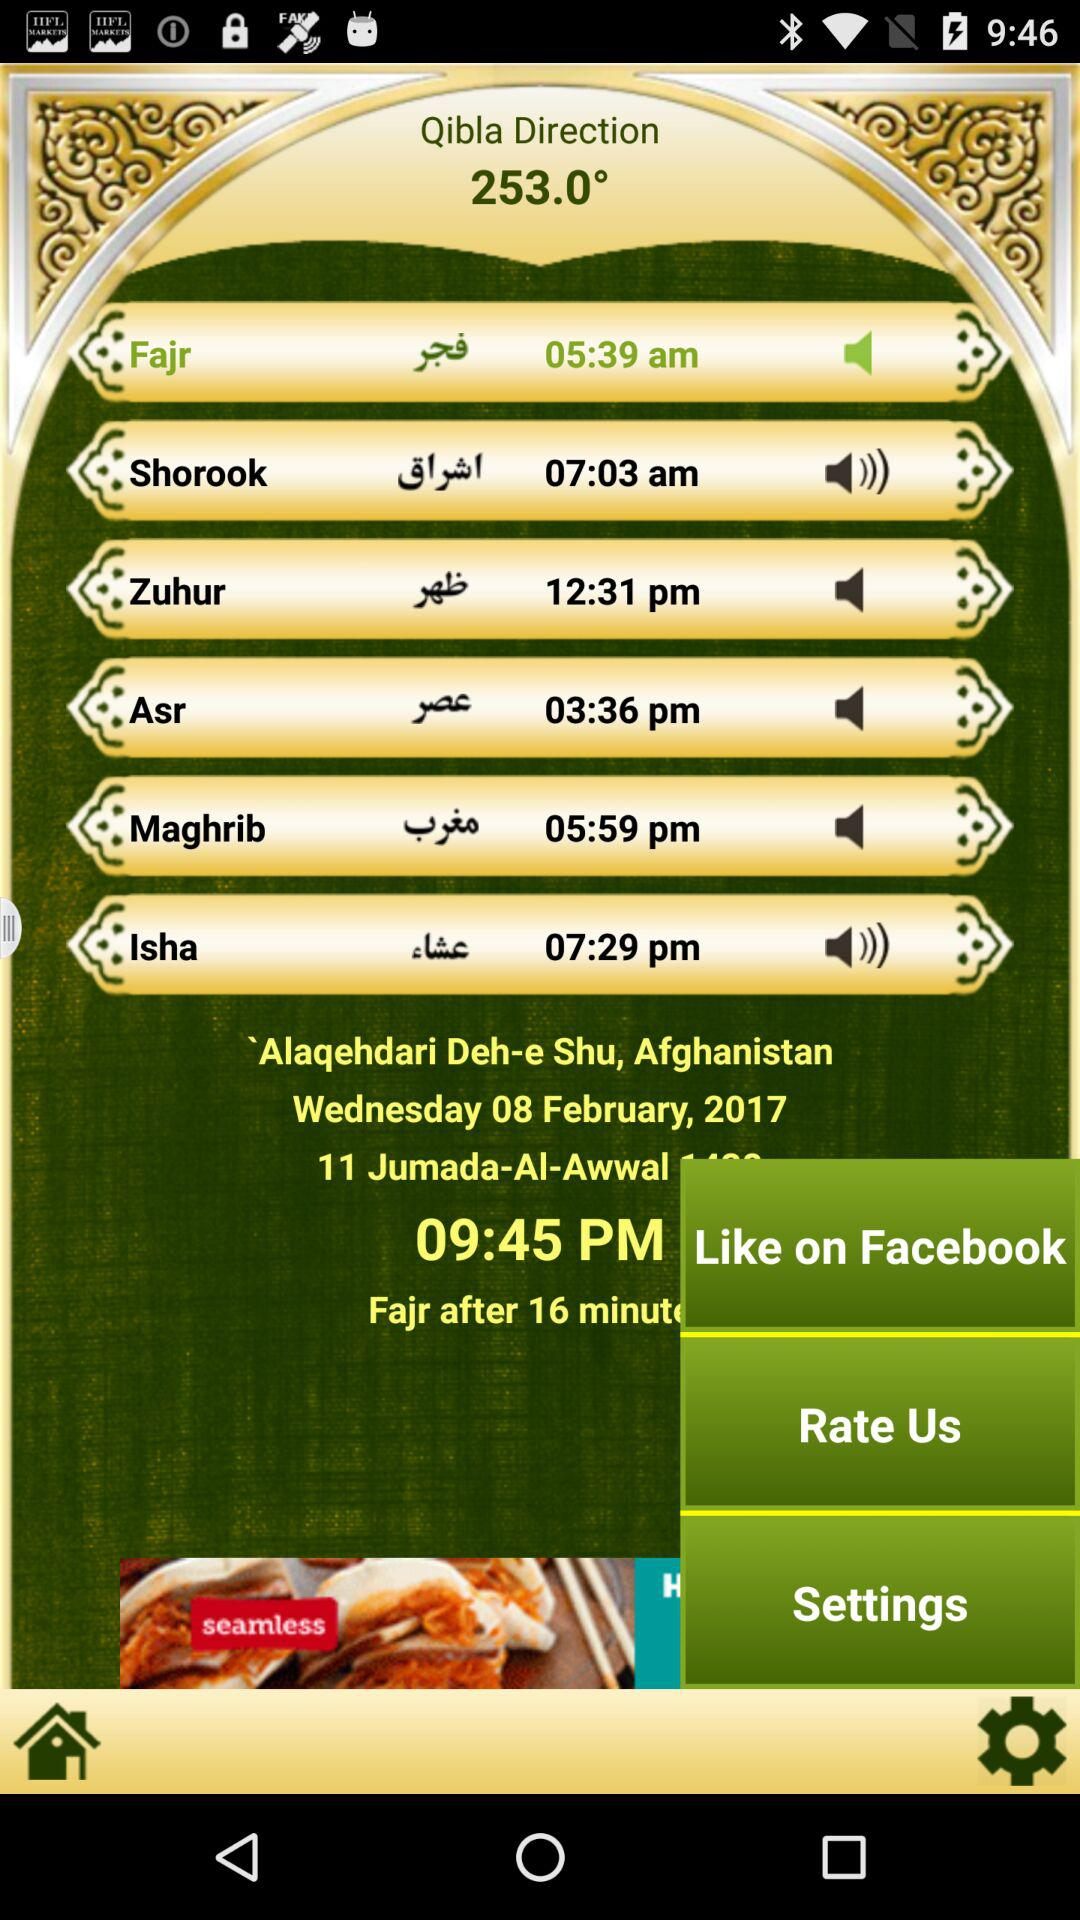Which prayer is done at 11:17 PM?
When the provided information is insufficient, respond with <no answer>. <no answer> 